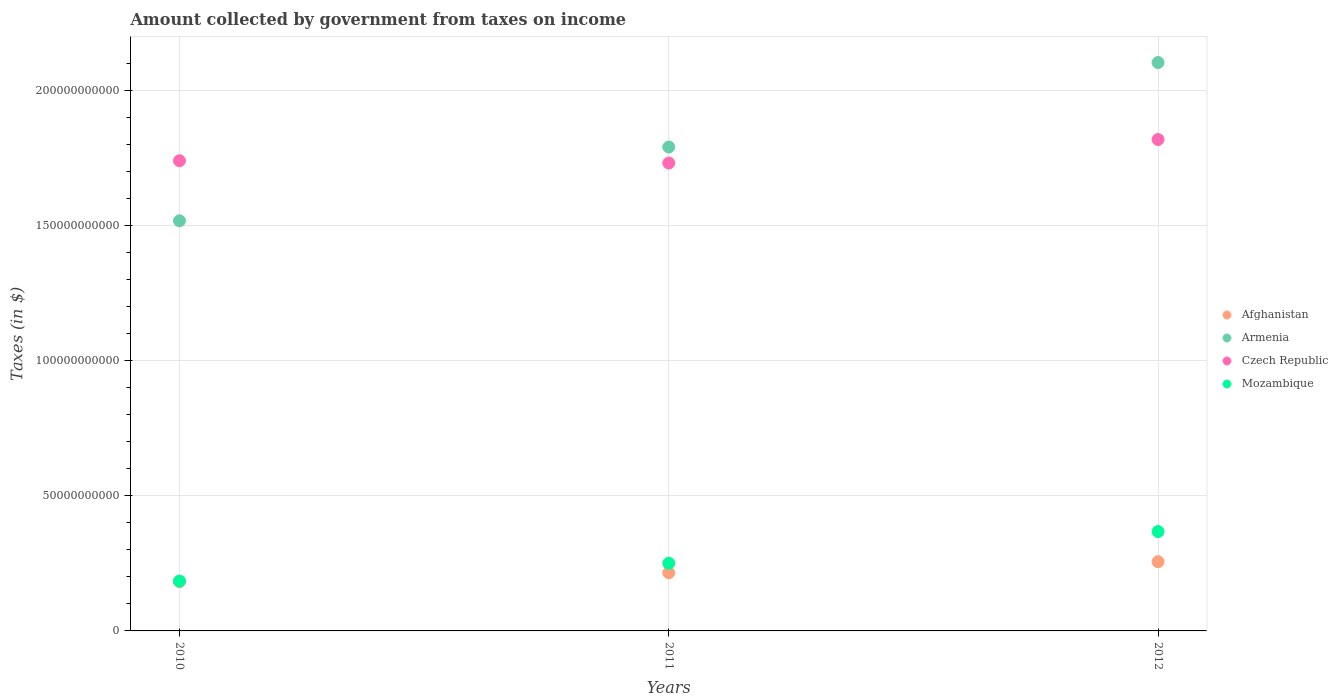How many different coloured dotlines are there?
Give a very brief answer. 4. Is the number of dotlines equal to the number of legend labels?
Your answer should be very brief. Yes. What is the amount collected by government from taxes on income in Czech Republic in 2011?
Your answer should be compact. 1.73e+11. Across all years, what is the maximum amount collected by government from taxes on income in Afghanistan?
Keep it short and to the point. 2.56e+1. Across all years, what is the minimum amount collected by government from taxes on income in Czech Republic?
Provide a succinct answer. 1.73e+11. In which year was the amount collected by government from taxes on income in Armenia minimum?
Offer a terse response. 2010. What is the total amount collected by government from taxes on income in Armenia in the graph?
Your response must be concise. 5.41e+11. What is the difference between the amount collected by government from taxes on income in Afghanistan in 2011 and that in 2012?
Your answer should be compact. -4.09e+09. What is the difference between the amount collected by government from taxes on income in Mozambique in 2011 and the amount collected by government from taxes on income in Afghanistan in 2012?
Keep it short and to the point. -5.78e+08. What is the average amount collected by government from taxes on income in Mozambique per year?
Your answer should be very brief. 2.67e+1. In the year 2010, what is the difference between the amount collected by government from taxes on income in Czech Republic and amount collected by government from taxes on income in Afghanistan?
Offer a terse response. 1.56e+11. In how many years, is the amount collected by government from taxes on income in Armenia greater than 30000000000 $?
Ensure brevity in your answer.  3. What is the ratio of the amount collected by government from taxes on income in Mozambique in 2011 to that in 2012?
Provide a short and direct response. 0.68. Is the amount collected by government from taxes on income in Mozambique in 2011 less than that in 2012?
Offer a terse response. Yes. What is the difference between the highest and the second highest amount collected by government from taxes on income in Czech Republic?
Offer a very short reply. 7.86e+09. What is the difference between the highest and the lowest amount collected by government from taxes on income in Mozambique?
Offer a very short reply. 1.83e+1. Is it the case that in every year, the sum of the amount collected by government from taxes on income in Armenia and amount collected by government from taxes on income in Afghanistan  is greater than the sum of amount collected by government from taxes on income in Mozambique and amount collected by government from taxes on income in Czech Republic?
Your answer should be compact. Yes. How many dotlines are there?
Your answer should be compact. 4. What is the difference between two consecutive major ticks on the Y-axis?
Keep it short and to the point. 5.00e+1. Are the values on the major ticks of Y-axis written in scientific E-notation?
Your answer should be compact. No. Does the graph contain any zero values?
Give a very brief answer. No. Does the graph contain grids?
Provide a short and direct response. Yes. How many legend labels are there?
Give a very brief answer. 4. How are the legend labels stacked?
Keep it short and to the point. Vertical. What is the title of the graph?
Provide a short and direct response. Amount collected by government from taxes on income. What is the label or title of the Y-axis?
Offer a terse response. Taxes (in $). What is the Taxes (in $) in Afghanistan in 2010?
Offer a terse response. 1.82e+1. What is the Taxes (in $) of Armenia in 2010?
Your answer should be very brief. 1.52e+11. What is the Taxes (in $) of Czech Republic in 2010?
Provide a succinct answer. 1.74e+11. What is the Taxes (in $) of Mozambique in 2010?
Your response must be concise. 1.84e+1. What is the Taxes (in $) in Afghanistan in 2011?
Offer a very short reply. 2.15e+1. What is the Taxes (in $) in Armenia in 2011?
Offer a very short reply. 1.79e+11. What is the Taxes (in $) of Czech Republic in 2011?
Ensure brevity in your answer.  1.73e+11. What is the Taxes (in $) of Mozambique in 2011?
Offer a terse response. 2.50e+1. What is the Taxes (in $) in Afghanistan in 2012?
Give a very brief answer. 2.56e+1. What is the Taxes (in $) in Armenia in 2012?
Your response must be concise. 2.10e+11. What is the Taxes (in $) in Czech Republic in 2012?
Offer a very short reply. 1.82e+11. What is the Taxes (in $) of Mozambique in 2012?
Keep it short and to the point. 3.68e+1. Across all years, what is the maximum Taxes (in $) of Afghanistan?
Your answer should be compact. 2.56e+1. Across all years, what is the maximum Taxes (in $) of Armenia?
Offer a very short reply. 2.10e+11. Across all years, what is the maximum Taxes (in $) of Czech Republic?
Provide a succinct answer. 1.82e+11. Across all years, what is the maximum Taxes (in $) in Mozambique?
Your answer should be very brief. 3.68e+1. Across all years, what is the minimum Taxes (in $) of Afghanistan?
Provide a succinct answer. 1.82e+1. Across all years, what is the minimum Taxes (in $) in Armenia?
Provide a succinct answer. 1.52e+11. Across all years, what is the minimum Taxes (in $) in Czech Republic?
Offer a very short reply. 1.73e+11. Across all years, what is the minimum Taxes (in $) in Mozambique?
Offer a terse response. 1.84e+1. What is the total Taxes (in $) in Afghanistan in the graph?
Provide a succinct answer. 6.54e+1. What is the total Taxes (in $) in Armenia in the graph?
Offer a terse response. 5.41e+11. What is the total Taxes (in $) in Czech Republic in the graph?
Provide a short and direct response. 5.29e+11. What is the total Taxes (in $) of Mozambique in the graph?
Your answer should be compact. 8.02e+1. What is the difference between the Taxes (in $) in Afghanistan in 2010 and that in 2011?
Provide a short and direct response. -3.27e+09. What is the difference between the Taxes (in $) in Armenia in 2010 and that in 2011?
Offer a terse response. -2.73e+1. What is the difference between the Taxes (in $) in Czech Republic in 2010 and that in 2011?
Give a very brief answer. 8.53e+08. What is the difference between the Taxes (in $) in Mozambique in 2010 and that in 2011?
Your response must be concise. -6.60e+09. What is the difference between the Taxes (in $) of Afghanistan in 2010 and that in 2012?
Your answer should be compact. -7.36e+09. What is the difference between the Taxes (in $) of Armenia in 2010 and that in 2012?
Give a very brief answer. -5.86e+1. What is the difference between the Taxes (in $) of Czech Republic in 2010 and that in 2012?
Provide a succinct answer. -7.86e+09. What is the difference between the Taxes (in $) in Mozambique in 2010 and that in 2012?
Offer a very short reply. -1.83e+1. What is the difference between the Taxes (in $) of Afghanistan in 2011 and that in 2012?
Your answer should be very brief. -4.09e+09. What is the difference between the Taxes (in $) in Armenia in 2011 and that in 2012?
Offer a terse response. -3.13e+1. What is the difference between the Taxes (in $) of Czech Republic in 2011 and that in 2012?
Your answer should be very brief. -8.71e+09. What is the difference between the Taxes (in $) of Mozambique in 2011 and that in 2012?
Your response must be concise. -1.17e+1. What is the difference between the Taxes (in $) in Afghanistan in 2010 and the Taxes (in $) in Armenia in 2011?
Provide a succinct answer. -1.61e+11. What is the difference between the Taxes (in $) in Afghanistan in 2010 and the Taxes (in $) in Czech Republic in 2011?
Give a very brief answer. -1.55e+11. What is the difference between the Taxes (in $) of Afghanistan in 2010 and the Taxes (in $) of Mozambique in 2011?
Offer a terse response. -6.79e+09. What is the difference between the Taxes (in $) of Armenia in 2010 and the Taxes (in $) of Czech Republic in 2011?
Provide a short and direct response. -2.14e+1. What is the difference between the Taxes (in $) in Armenia in 2010 and the Taxes (in $) in Mozambique in 2011?
Ensure brevity in your answer.  1.27e+11. What is the difference between the Taxes (in $) of Czech Republic in 2010 and the Taxes (in $) of Mozambique in 2011?
Provide a succinct answer. 1.49e+11. What is the difference between the Taxes (in $) of Afghanistan in 2010 and the Taxes (in $) of Armenia in 2012?
Make the answer very short. -1.92e+11. What is the difference between the Taxes (in $) of Afghanistan in 2010 and the Taxes (in $) of Czech Republic in 2012?
Your answer should be compact. -1.64e+11. What is the difference between the Taxes (in $) of Afghanistan in 2010 and the Taxes (in $) of Mozambique in 2012?
Provide a short and direct response. -1.85e+1. What is the difference between the Taxes (in $) in Armenia in 2010 and the Taxes (in $) in Czech Republic in 2012?
Offer a very short reply. -3.01e+1. What is the difference between the Taxes (in $) of Armenia in 2010 and the Taxes (in $) of Mozambique in 2012?
Ensure brevity in your answer.  1.15e+11. What is the difference between the Taxes (in $) in Czech Republic in 2010 and the Taxes (in $) in Mozambique in 2012?
Keep it short and to the point. 1.37e+11. What is the difference between the Taxes (in $) of Afghanistan in 2011 and the Taxes (in $) of Armenia in 2012?
Offer a very short reply. -1.89e+11. What is the difference between the Taxes (in $) of Afghanistan in 2011 and the Taxes (in $) of Czech Republic in 2012?
Make the answer very short. -1.60e+11. What is the difference between the Taxes (in $) of Afghanistan in 2011 and the Taxes (in $) of Mozambique in 2012?
Your answer should be compact. -1.53e+1. What is the difference between the Taxes (in $) of Armenia in 2011 and the Taxes (in $) of Czech Republic in 2012?
Give a very brief answer. -2.79e+09. What is the difference between the Taxes (in $) of Armenia in 2011 and the Taxes (in $) of Mozambique in 2012?
Your response must be concise. 1.42e+11. What is the difference between the Taxes (in $) in Czech Republic in 2011 and the Taxes (in $) in Mozambique in 2012?
Your answer should be compact. 1.36e+11. What is the average Taxes (in $) of Afghanistan per year?
Provide a succinct answer. 2.18e+1. What is the average Taxes (in $) of Armenia per year?
Your answer should be very brief. 1.80e+11. What is the average Taxes (in $) of Czech Republic per year?
Keep it short and to the point. 1.76e+11. What is the average Taxes (in $) in Mozambique per year?
Your answer should be very brief. 2.67e+1. In the year 2010, what is the difference between the Taxes (in $) of Afghanistan and Taxes (in $) of Armenia?
Provide a succinct answer. -1.34e+11. In the year 2010, what is the difference between the Taxes (in $) of Afghanistan and Taxes (in $) of Czech Republic?
Offer a very short reply. -1.56e+11. In the year 2010, what is the difference between the Taxes (in $) of Afghanistan and Taxes (in $) of Mozambique?
Offer a terse response. -1.89e+08. In the year 2010, what is the difference between the Taxes (in $) in Armenia and Taxes (in $) in Czech Republic?
Provide a short and direct response. -2.22e+1. In the year 2010, what is the difference between the Taxes (in $) of Armenia and Taxes (in $) of Mozambique?
Your answer should be very brief. 1.33e+11. In the year 2010, what is the difference between the Taxes (in $) in Czech Republic and Taxes (in $) in Mozambique?
Your answer should be very brief. 1.56e+11. In the year 2011, what is the difference between the Taxes (in $) in Afghanistan and Taxes (in $) in Armenia?
Your answer should be very brief. -1.58e+11. In the year 2011, what is the difference between the Taxes (in $) in Afghanistan and Taxes (in $) in Czech Republic?
Keep it short and to the point. -1.52e+11. In the year 2011, what is the difference between the Taxes (in $) in Afghanistan and Taxes (in $) in Mozambique?
Give a very brief answer. -3.52e+09. In the year 2011, what is the difference between the Taxes (in $) in Armenia and Taxes (in $) in Czech Republic?
Give a very brief answer. 5.92e+09. In the year 2011, what is the difference between the Taxes (in $) of Armenia and Taxes (in $) of Mozambique?
Give a very brief answer. 1.54e+11. In the year 2011, what is the difference between the Taxes (in $) in Czech Republic and Taxes (in $) in Mozambique?
Ensure brevity in your answer.  1.48e+11. In the year 2012, what is the difference between the Taxes (in $) in Afghanistan and Taxes (in $) in Armenia?
Your response must be concise. -1.85e+11. In the year 2012, what is the difference between the Taxes (in $) of Afghanistan and Taxes (in $) of Czech Republic?
Keep it short and to the point. -1.56e+11. In the year 2012, what is the difference between the Taxes (in $) in Afghanistan and Taxes (in $) in Mozambique?
Your answer should be compact. -1.12e+1. In the year 2012, what is the difference between the Taxes (in $) of Armenia and Taxes (in $) of Czech Republic?
Ensure brevity in your answer.  2.85e+1. In the year 2012, what is the difference between the Taxes (in $) of Armenia and Taxes (in $) of Mozambique?
Ensure brevity in your answer.  1.74e+11. In the year 2012, what is the difference between the Taxes (in $) of Czech Republic and Taxes (in $) of Mozambique?
Give a very brief answer. 1.45e+11. What is the ratio of the Taxes (in $) in Afghanistan in 2010 to that in 2011?
Your answer should be compact. 0.85. What is the ratio of the Taxes (in $) of Armenia in 2010 to that in 2011?
Offer a very short reply. 0.85. What is the ratio of the Taxes (in $) in Mozambique in 2010 to that in 2011?
Ensure brevity in your answer.  0.74. What is the ratio of the Taxes (in $) of Afghanistan in 2010 to that in 2012?
Give a very brief answer. 0.71. What is the ratio of the Taxes (in $) in Armenia in 2010 to that in 2012?
Offer a terse response. 0.72. What is the ratio of the Taxes (in $) in Czech Republic in 2010 to that in 2012?
Ensure brevity in your answer.  0.96. What is the ratio of the Taxes (in $) in Mozambique in 2010 to that in 2012?
Give a very brief answer. 0.5. What is the ratio of the Taxes (in $) of Afghanistan in 2011 to that in 2012?
Provide a short and direct response. 0.84. What is the ratio of the Taxes (in $) in Armenia in 2011 to that in 2012?
Your answer should be very brief. 0.85. What is the ratio of the Taxes (in $) in Czech Republic in 2011 to that in 2012?
Your response must be concise. 0.95. What is the ratio of the Taxes (in $) in Mozambique in 2011 to that in 2012?
Offer a very short reply. 0.68. What is the difference between the highest and the second highest Taxes (in $) in Afghanistan?
Your answer should be compact. 4.09e+09. What is the difference between the highest and the second highest Taxes (in $) in Armenia?
Provide a short and direct response. 3.13e+1. What is the difference between the highest and the second highest Taxes (in $) of Czech Republic?
Offer a very short reply. 7.86e+09. What is the difference between the highest and the second highest Taxes (in $) of Mozambique?
Your response must be concise. 1.17e+1. What is the difference between the highest and the lowest Taxes (in $) in Afghanistan?
Offer a very short reply. 7.36e+09. What is the difference between the highest and the lowest Taxes (in $) in Armenia?
Your answer should be very brief. 5.86e+1. What is the difference between the highest and the lowest Taxes (in $) in Czech Republic?
Offer a very short reply. 8.71e+09. What is the difference between the highest and the lowest Taxes (in $) in Mozambique?
Keep it short and to the point. 1.83e+1. 